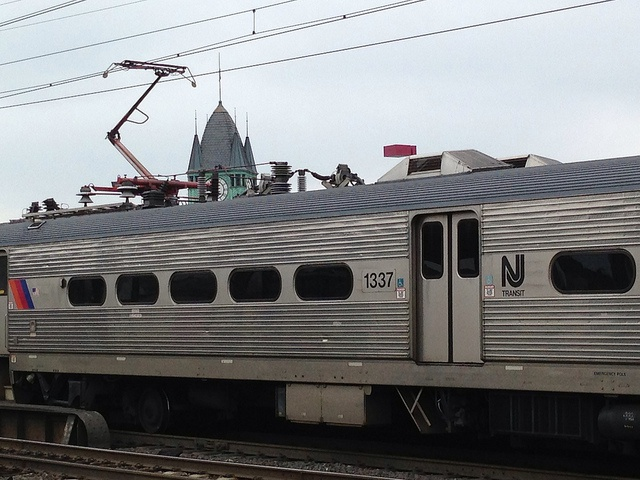Describe the objects in this image and their specific colors. I can see train in white, black, gray, and darkgray tones and clock in white, gray, darkgray, lightgray, and black tones in this image. 